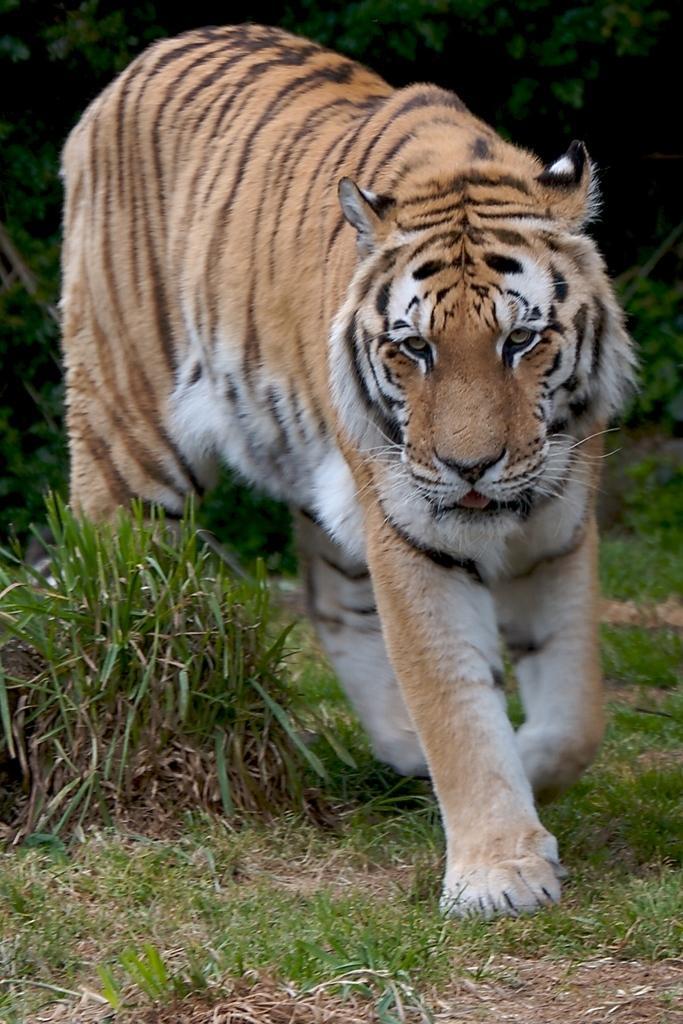Can you describe this image briefly? In this picture we can see a tiger on the ground and in the background we can see trees. 